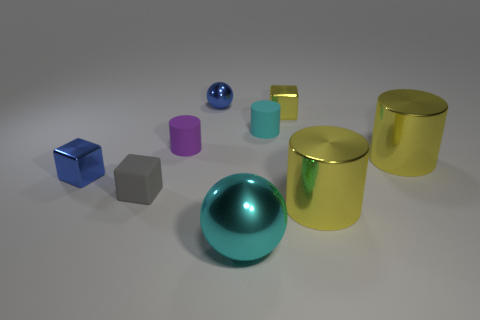Are there fewer tiny metal blocks that are behind the yellow block than tiny yellow things that are on the left side of the small blue metal block?
Give a very brief answer. No. How many other things are the same shape as the tiny yellow shiny object?
Your answer should be compact. 2. What shape is the cyan thing that is the same material as the gray cube?
Give a very brief answer. Cylinder. There is a small thing that is both behind the tiny cyan cylinder and right of the cyan metallic object; what color is it?
Offer a terse response. Yellow. Is the sphere behind the yellow metallic cube made of the same material as the small blue cube?
Provide a succinct answer. Yes. Is the number of big yellow objects that are on the left side of the large cyan thing less than the number of tiny yellow shiny objects?
Give a very brief answer. Yes. Are there any small things that have the same material as the small blue ball?
Offer a terse response. Yes. Does the cyan sphere have the same size as the blue metal thing that is on the left side of the tiny metal ball?
Your answer should be compact. No. Is there a matte block that has the same color as the large shiny ball?
Provide a succinct answer. No. Does the small cyan thing have the same material as the purple thing?
Your response must be concise. Yes. 